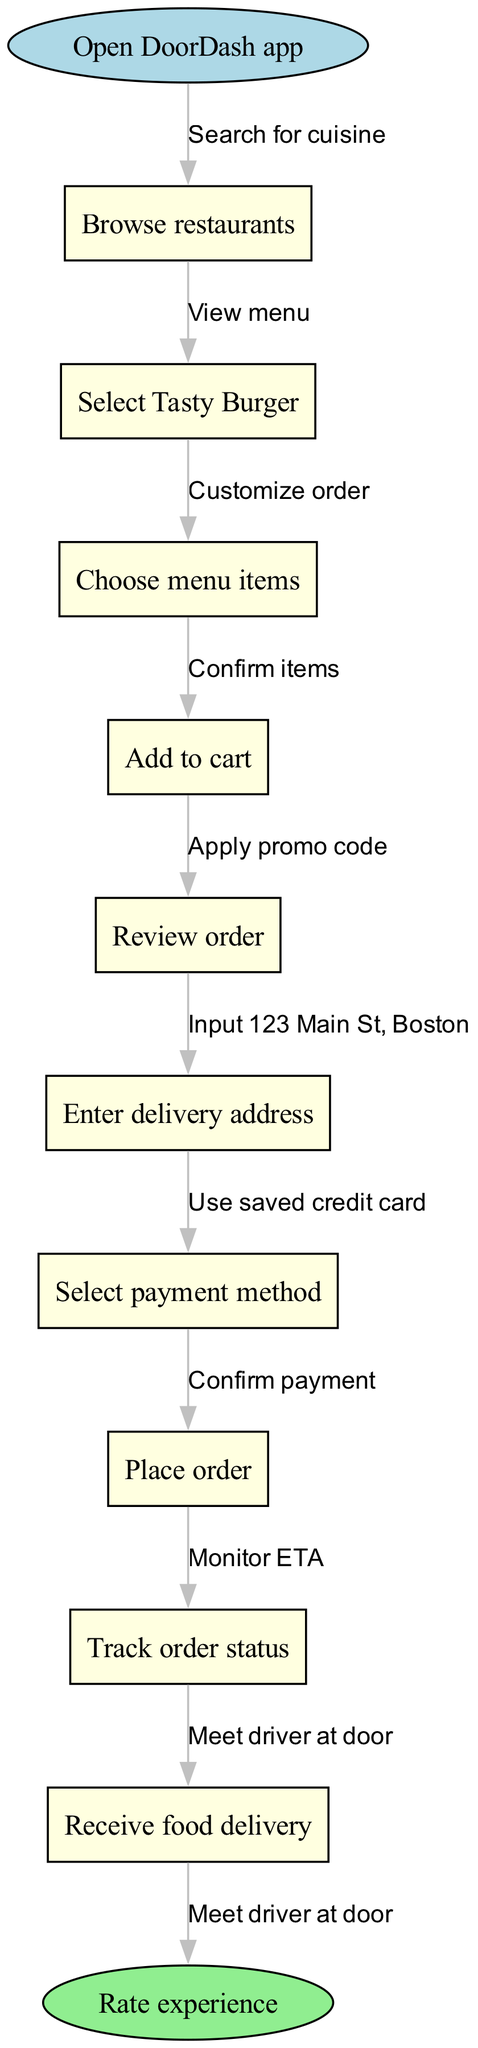What is the first step in the workflow? The diagram starts with the "Open DoorDash app" node, indicating that this is the initial action in the food delivery process.
Answer: Open DoorDash app How many total nodes are in the diagram? The diagram includes one start node, multiple intermediate nodes (10 in total), and one end node, resulting in a total of 12 nodes.
Answer: 12 What is the last action taken before receiving the food delivery? Before receiving the food delivery, the last action depicted is "Track order status," which allows users to see where their order is.
Answer: Track order status Which node follows "Select Tasty Burger"? The node that follows "Select Tasty Burger" is "Choose menu items," indicating the next action in the sequence of ordering food.
Answer: Choose menu items What is the purpose of the "Rate experience" node? The "Rate experience" node serves as the endpoint of the flow, allowing users to provide feedback after their food delivery, thus concluding the ordering process.
Answer: Rate experience If a user placed an order, what would be the resultant action after "Confirm payment"? After "Confirm payment," the next action is "Track order status," indicating that the user can monitor the order after successfully making a payment.
Answer: Track order status What edge connects the start node to the first intermediate node? The edge that connects the "Open DoorDash app" start node to the first intermediate node, "Browse restaurants," is labeled "Search for cuisine."
Answer: Search for cuisine How is the delivery address entered in the workflow? The "Enter delivery address" step is completed by the action labeled "Input 123 Main St, Boston," indicating the specific way the address is provided.
Answer: Input 123 Main St, Boston Which payment method is mentioned in the diagram? The diagram mentions "Use saved credit card" as a specific payment method, indicating that users can utilize previously saved payment information during checkout.
Answer: Use saved credit card 